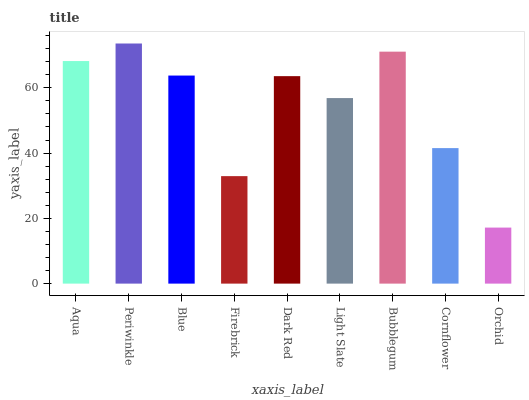Is Blue the minimum?
Answer yes or no. No. Is Blue the maximum?
Answer yes or no. No. Is Periwinkle greater than Blue?
Answer yes or no. Yes. Is Blue less than Periwinkle?
Answer yes or no. Yes. Is Blue greater than Periwinkle?
Answer yes or no. No. Is Periwinkle less than Blue?
Answer yes or no. No. Is Dark Red the high median?
Answer yes or no. Yes. Is Dark Red the low median?
Answer yes or no. Yes. Is Firebrick the high median?
Answer yes or no. No. Is Light Slate the low median?
Answer yes or no. No. 